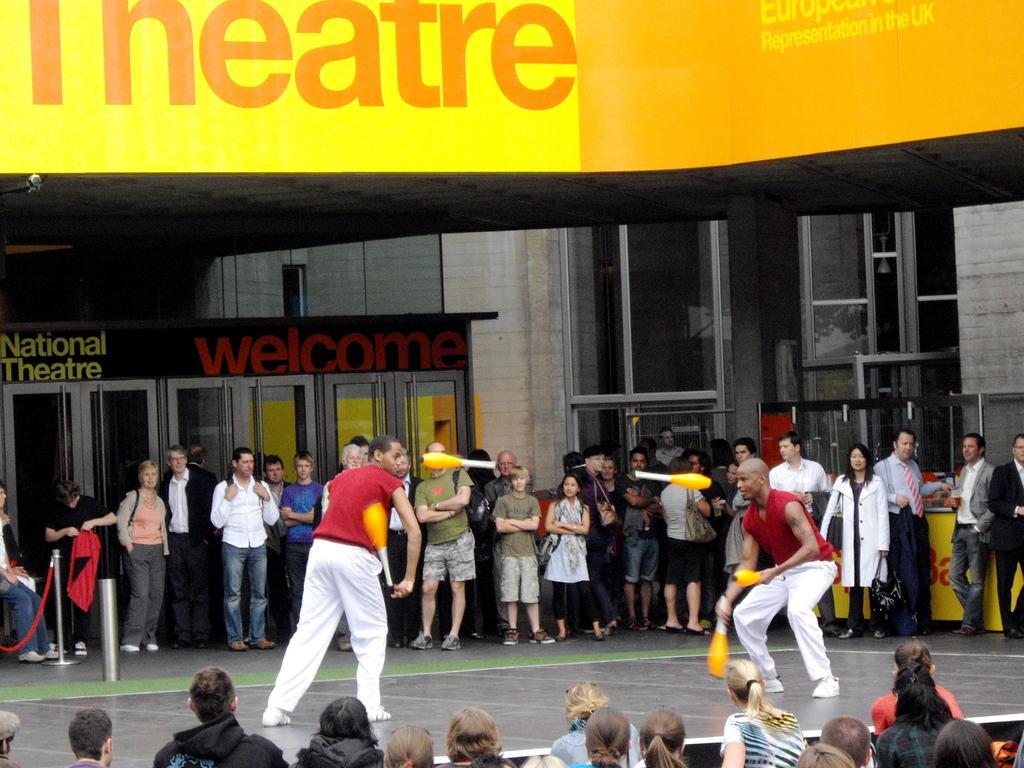How would you summarize this image in a sentence or two? There are two persons wearing red dress are standing and playing with yellow color object in front of them and there are few people standing on either sides of them. 